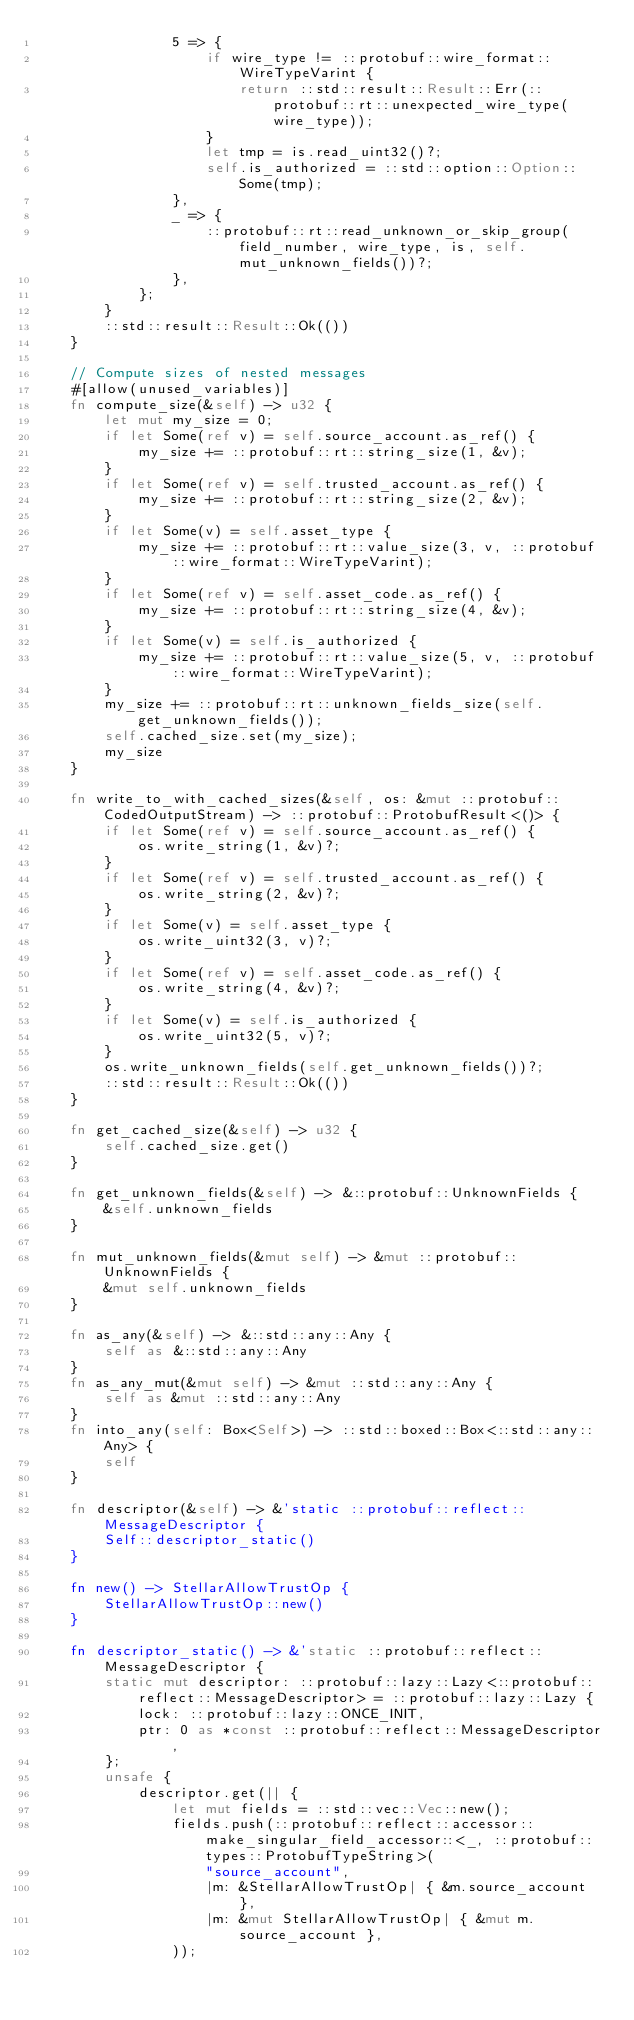Convert code to text. <code><loc_0><loc_0><loc_500><loc_500><_Rust_>                5 => {
                    if wire_type != ::protobuf::wire_format::WireTypeVarint {
                        return ::std::result::Result::Err(::protobuf::rt::unexpected_wire_type(wire_type));
                    }
                    let tmp = is.read_uint32()?;
                    self.is_authorized = ::std::option::Option::Some(tmp);
                },
                _ => {
                    ::protobuf::rt::read_unknown_or_skip_group(field_number, wire_type, is, self.mut_unknown_fields())?;
                },
            };
        }
        ::std::result::Result::Ok(())
    }

    // Compute sizes of nested messages
    #[allow(unused_variables)]
    fn compute_size(&self) -> u32 {
        let mut my_size = 0;
        if let Some(ref v) = self.source_account.as_ref() {
            my_size += ::protobuf::rt::string_size(1, &v);
        }
        if let Some(ref v) = self.trusted_account.as_ref() {
            my_size += ::protobuf::rt::string_size(2, &v);
        }
        if let Some(v) = self.asset_type {
            my_size += ::protobuf::rt::value_size(3, v, ::protobuf::wire_format::WireTypeVarint);
        }
        if let Some(ref v) = self.asset_code.as_ref() {
            my_size += ::protobuf::rt::string_size(4, &v);
        }
        if let Some(v) = self.is_authorized {
            my_size += ::protobuf::rt::value_size(5, v, ::protobuf::wire_format::WireTypeVarint);
        }
        my_size += ::protobuf::rt::unknown_fields_size(self.get_unknown_fields());
        self.cached_size.set(my_size);
        my_size
    }

    fn write_to_with_cached_sizes(&self, os: &mut ::protobuf::CodedOutputStream) -> ::protobuf::ProtobufResult<()> {
        if let Some(ref v) = self.source_account.as_ref() {
            os.write_string(1, &v)?;
        }
        if let Some(ref v) = self.trusted_account.as_ref() {
            os.write_string(2, &v)?;
        }
        if let Some(v) = self.asset_type {
            os.write_uint32(3, v)?;
        }
        if let Some(ref v) = self.asset_code.as_ref() {
            os.write_string(4, &v)?;
        }
        if let Some(v) = self.is_authorized {
            os.write_uint32(5, v)?;
        }
        os.write_unknown_fields(self.get_unknown_fields())?;
        ::std::result::Result::Ok(())
    }

    fn get_cached_size(&self) -> u32 {
        self.cached_size.get()
    }

    fn get_unknown_fields(&self) -> &::protobuf::UnknownFields {
        &self.unknown_fields
    }

    fn mut_unknown_fields(&mut self) -> &mut ::protobuf::UnknownFields {
        &mut self.unknown_fields
    }

    fn as_any(&self) -> &::std::any::Any {
        self as &::std::any::Any
    }
    fn as_any_mut(&mut self) -> &mut ::std::any::Any {
        self as &mut ::std::any::Any
    }
    fn into_any(self: Box<Self>) -> ::std::boxed::Box<::std::any::Any> {
        self
    }

    fn descriptor(&self) -> &'static ::protobuf::reflect::MessageDescriptor {
        Self::descriptor_static()
    }

    fn new() -> StellarAllowTrustOp {
        StellarAllowTrustOp::new()
    }

    fn descriptor_static() -> &'static ::protobuf::reflect::MessageDescriptor {
        static mut descriptor: ::protobuf::lazy::Lazy<::protobuf::reflect::MessageDescriptor> = ::protobuf::lazy::Lazy {
            lock: ::protobuf::lazy::ONCE_INIT,
            ptr: 0 as *const ::protobuf::reflect::MessageDescriptor,
        };
        unsafe {
            descriptor.get(|| {
                let mut fields = ::std::vec::Vec::new();
                fields.push(::protobuf::reflect::accessor::make_singular_field_accessor::<_, ::protobuf::types::ProtobufTypeString>(
                    "source_account",
                    |m: &StellarAllowTrustOp| { &m.source_account },
                    |m: &mut StellarAllowTrustOp| { &mut m.source_account },
                ));</code> 